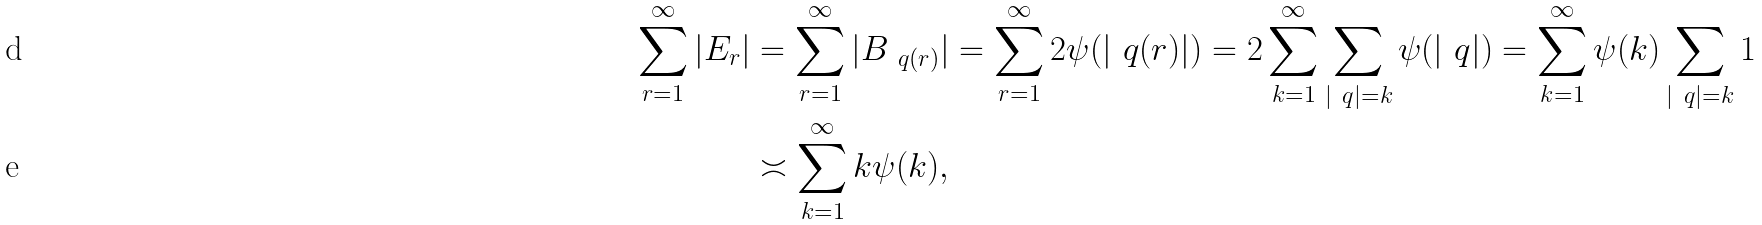<formula> <loc_0><loc_0><loc_500><loc_500>\sum _ { r = 1 } ^ { \infty } | E _ { r } | & = \sum _ { r = 1 } ^ { \infty } | B _ { \ q ( r ) } | = \sum _ { r = 1 } ^ { \infty } 2 \psi ( | \ q ( r ) | ) = 2 \sum _ { k = 1 } ^ { \infty } \sum _ { | \ q | = k } \psi ( | \ q | ) = \sum _ { k = 1 } ^ { \infty } \psi ( k ) \sum _ { | \ q | = k } 1 \\ & \asymp \sum _ { k = 1 } ^ { \infty } k \psi ( k ) ,</formula> 